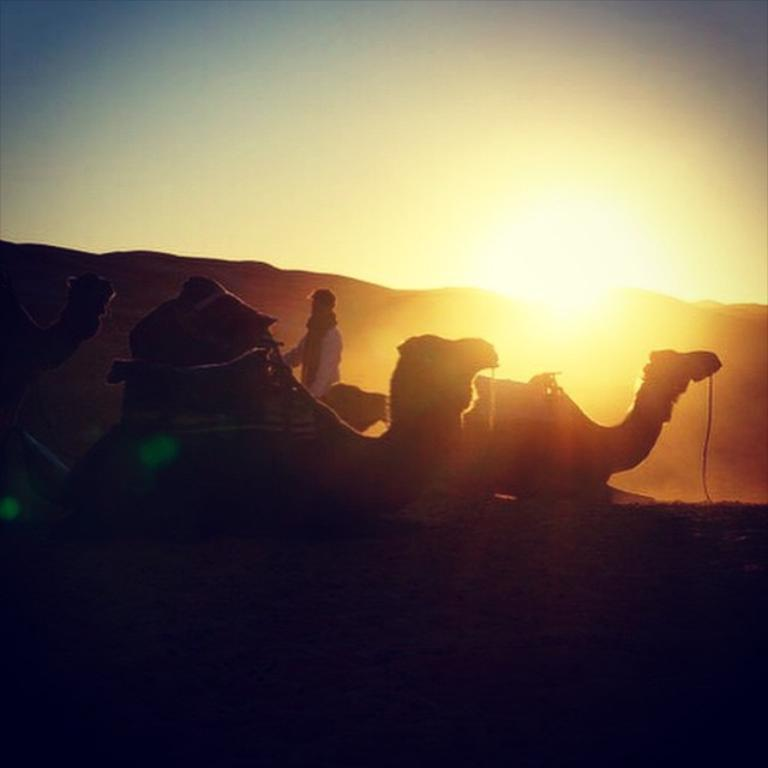How many people are in the image? There is one person in the image. What animals are present in the image? There are camels in the image. What type of terrain is visible in the image? The camels and person are on sand. What is visible in the background of the image? Sunlight and the sky are visible in the background. What type of fairies can be seen flying around the camels in the image? There are no fairies present in the image; it only features a person and camels on sand. What year is depicted in the image? The image does not depict a specific year; it is a snapshot of a scene with a person and camels on sand. 